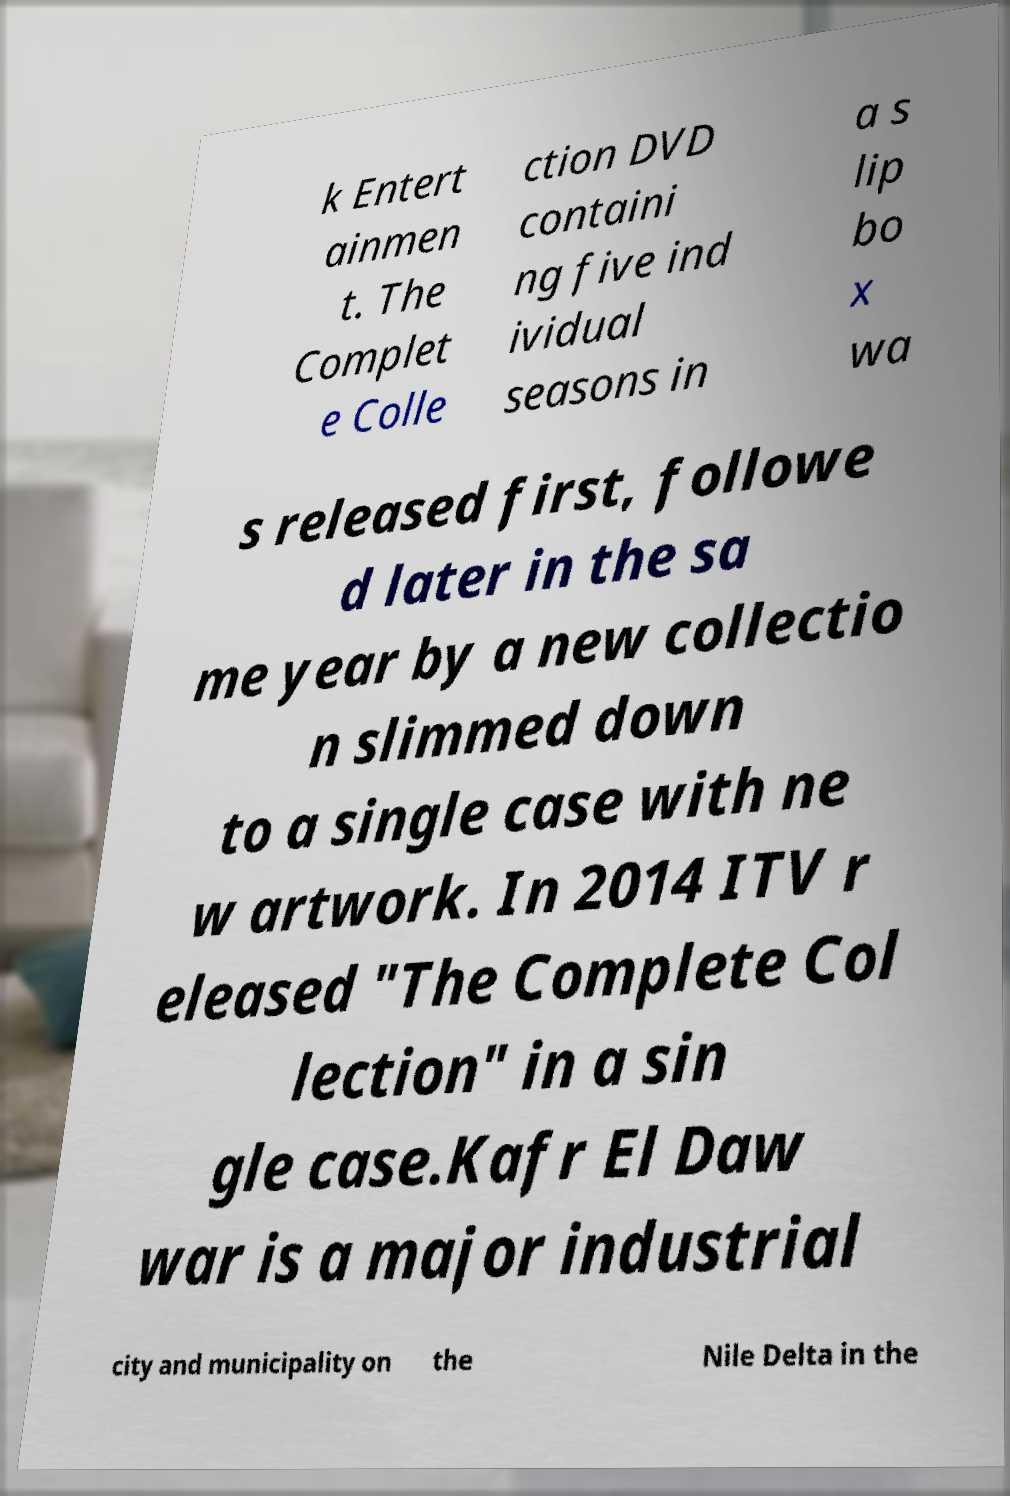Please read and relay the text visible in this image. What does it say? k Entert ainmen t. The Complet e Colle ction DVD containi ng five ind ividual seasons in a s lip bo x wa s released first, followe d later in the sa me year by a new collectio n slimmed down to a single case with ne w artwork. In 2014 ITV r eleased "The Complete Col lection" in a sin gle case.Kafr El Daw war is a major industrial city and municipality on the Nile Delta in the 